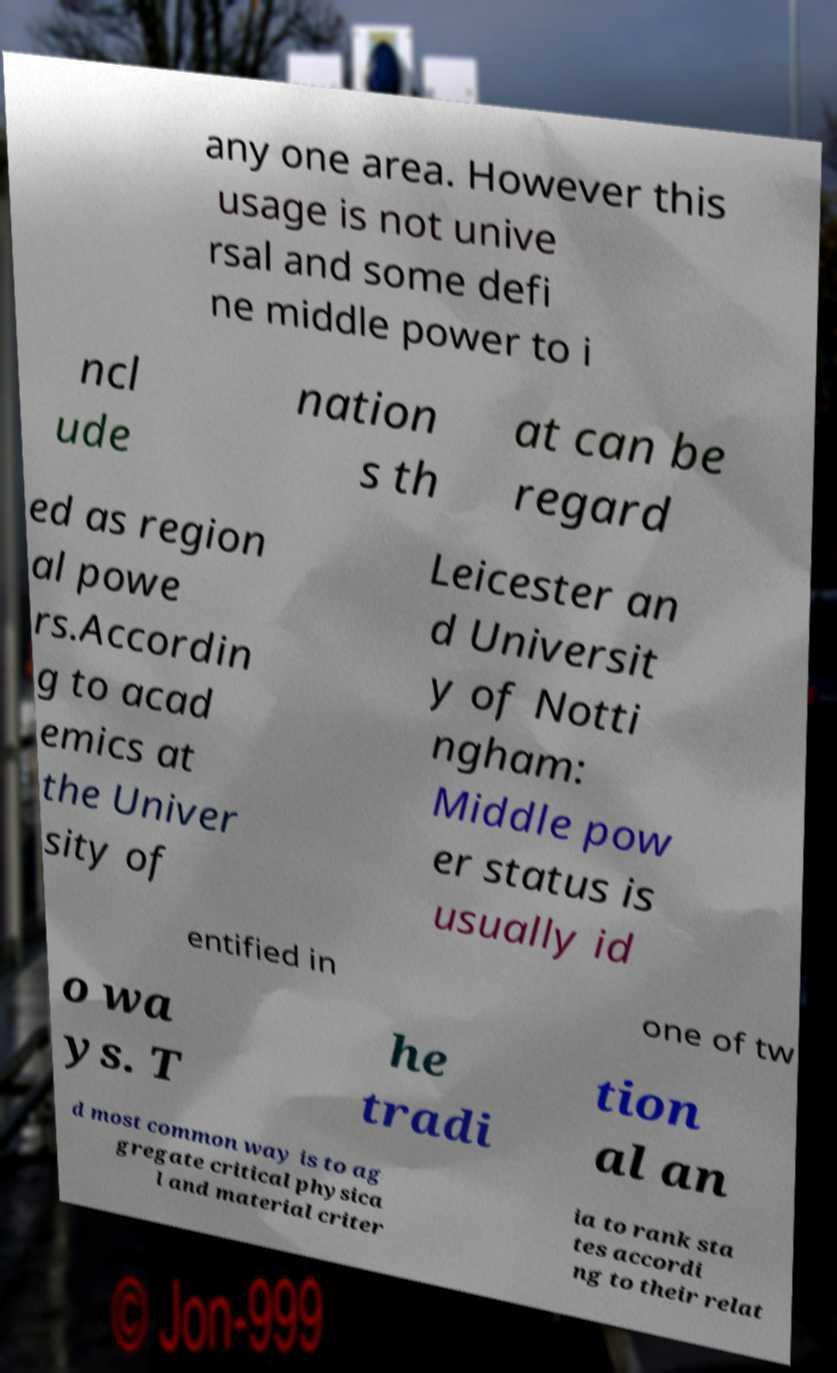I need the written content from this picture converted into text. Can you do that? any one area. However this usage is not unive rsal and some defi ne middle power to i ncl ude nation s th at can be regard ed as region al powe rs.Accordin g to acad emics at the Univer sity of Leicester an d Universit y of Notti ngham: Middle pow er status is usually id entified in one of tw o wa ys. T he tradi tion al an d most common way is to ag gregate critical physica l and material criter ia to rank sta tes accordi ng to their relat 